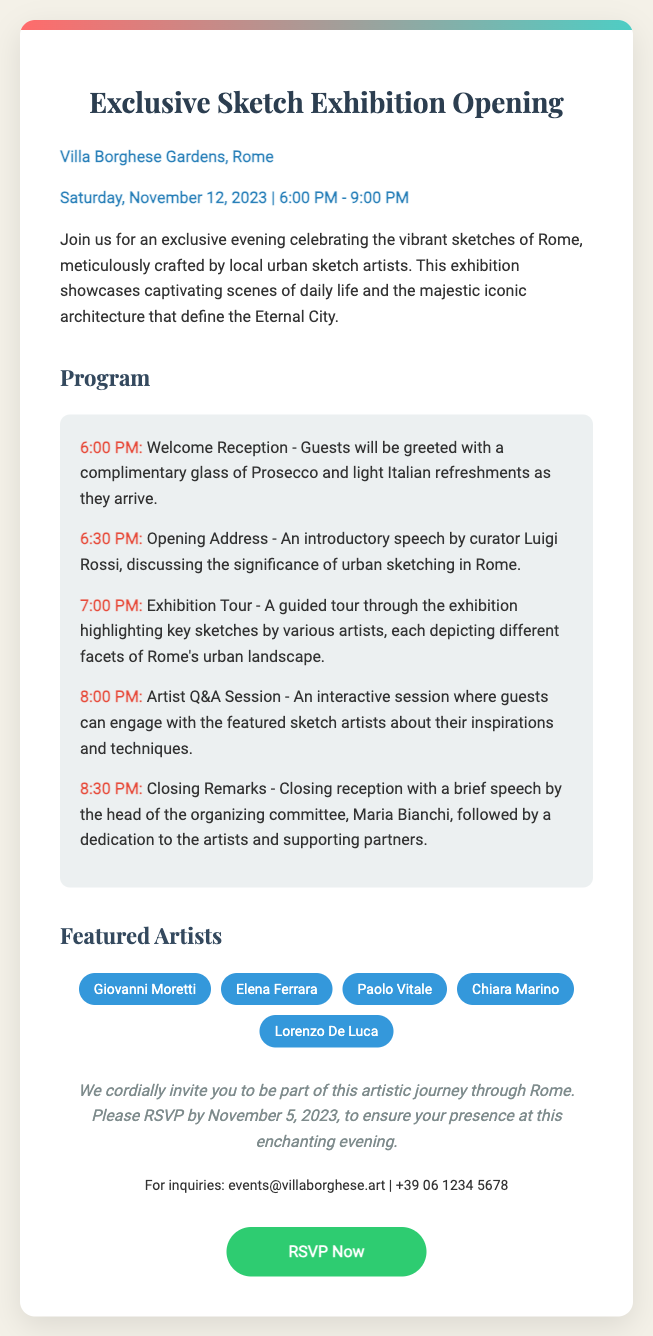What is the location of the event? The location of the event is mentioned prominently in the document as Villa Borghese Gardens, Rome.
Answer: Villa Borghese Gardens, Rome What is the date of the exhibition? The document states that the exhibition is on Saturday, November 12, 2023.
Answer: Saturday, November 12, 2023 Who is the curator of the exhibition? The document lists Luigi Rossi as the curator who will give the opening address.
Answer: Luigi Rossi What time does the welcome reception begin? According to the program in the document, the welcome reception starts at 6:00 PM.
Answer: 6:00 PM How many featured artists are mentioned? The document lists five artists, providing an overview of those featured in the exhibition.
Answer: Five What is the final event mentioned in the program? The last item in the program is the closing remarks by Maria Bianchi.
Answer: Closing Remarks What type of refreshments will be served during the welcome reception? The document specifies that light Italian refreshments will be provided.
Answer: Light Italian refreshments What is the RSVP deadline? The document mentions that the RSVP must be made by November 5, 2023.
Answer: November 5, 2023 What color is the RSVP button? The document describes the RSVP button's background color as green, specifically using the color code for representation.
Answer: Green 